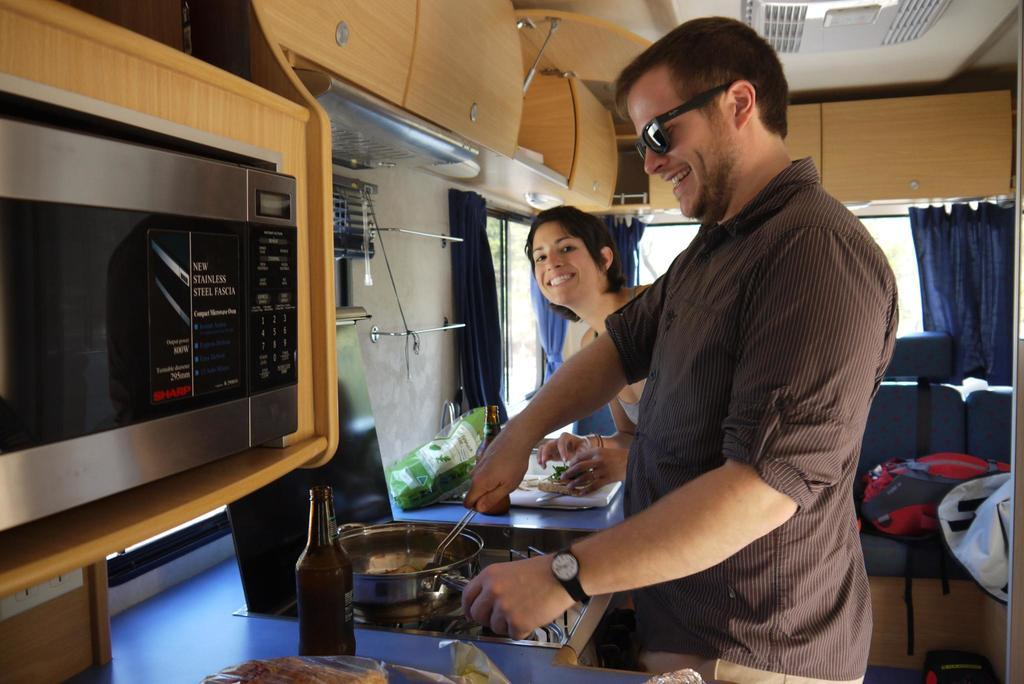<image>
Offer a succinct explanation of the picture presented. A man and woman are in a small kitchen that has a new stainless steel fascia labeled microwave. 